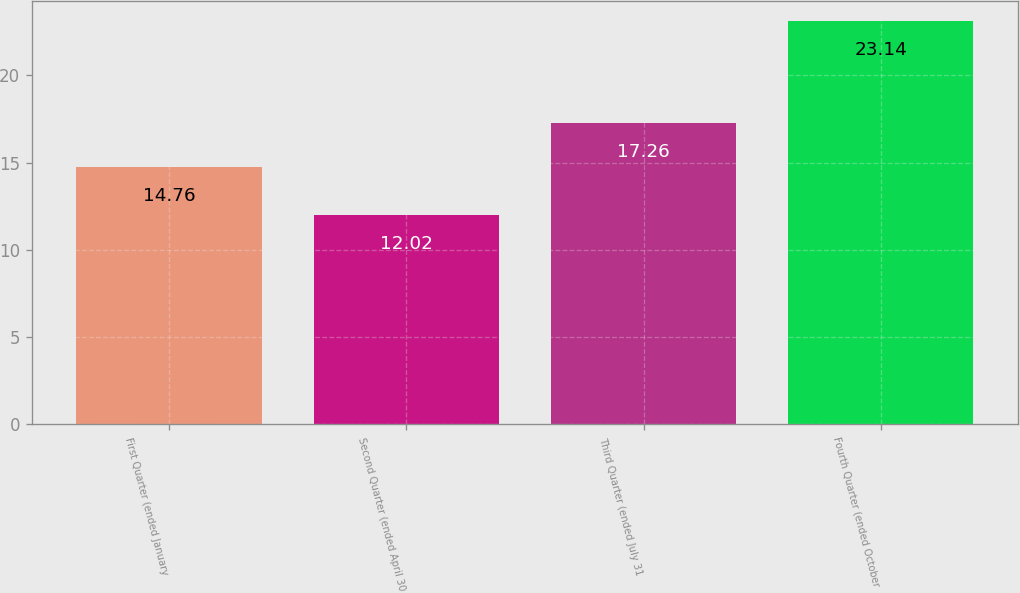<chart> <loc_0><loc_0><loc_500><loc_500><bar_chart><fcel>First Quarter (ended January<fcel>Second Quarter (ended April 30<fcel>Third Quarter (ended July 31<fcel>Fourth Quarter (ended October<nl><fcel>14.76<fcel>12.02<fcel>17.26<fcel>23.14<nl></chart> 